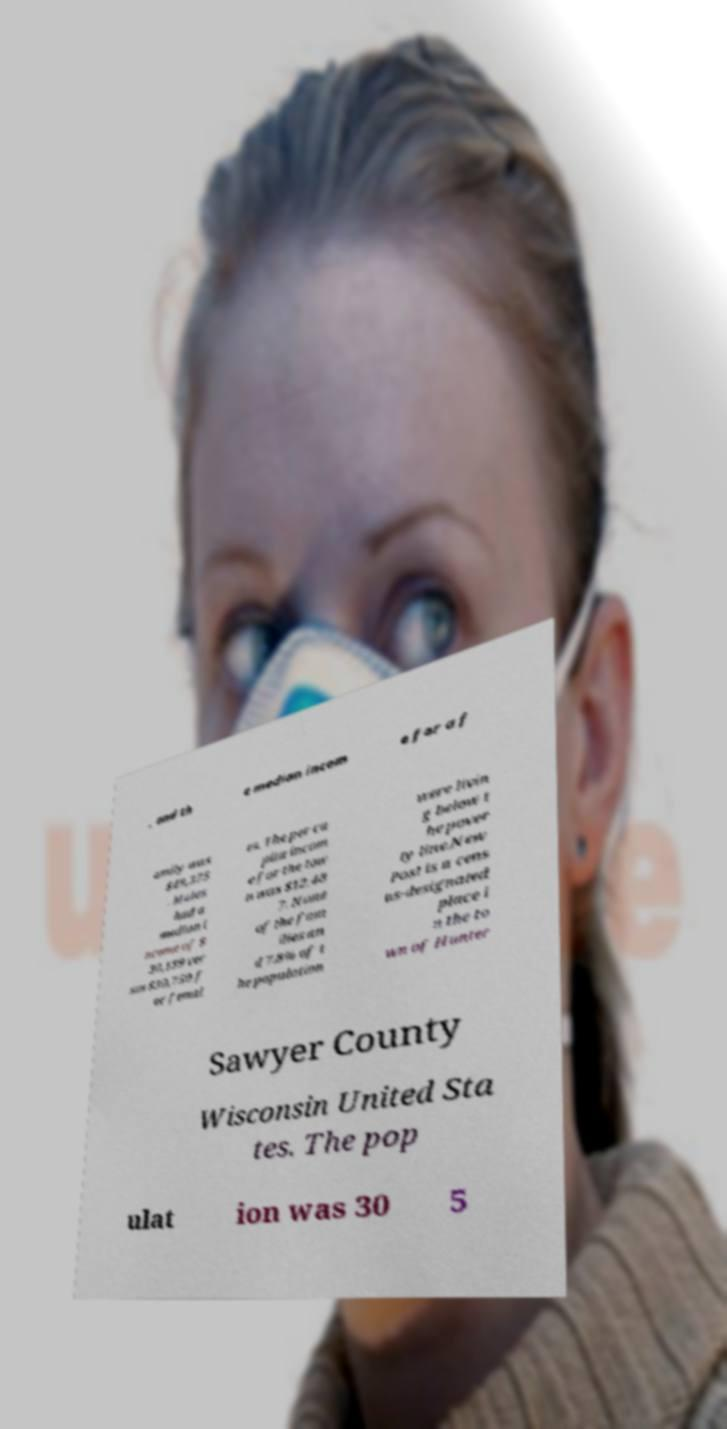Can you read and provide the text displayed in the image?This photo seems to have some interesting text. Can you extract and type it out for me? , and th e median incom e for a f amily was $49,375 . Males had a median i ncome of $ 30,139 ver sus $30,750 f or femal es. The per ca pita incom e for the tow n was $12,48 7. None of the fam ilies an d 7.8% of t he population were livin g below t he pover ty line.New Post is a cens us-designated place i n the to wn of Hunter Sawyer County Wisconsin United Sta tes. The pop ulat ion was 30 5 